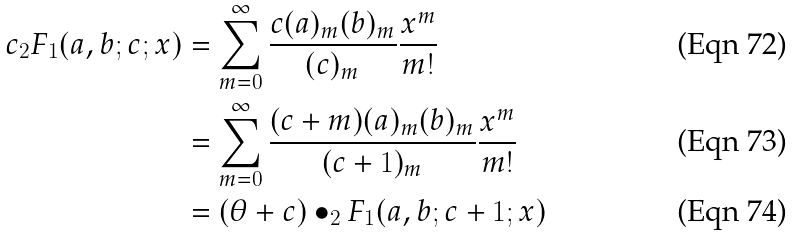<formula> <loc_0><loc_0><loc_500><loc_500>c _ { 2 } F _ { 1 } ( a , b ; c ; x ) & = \sum _ { m = 0 } ^ { \infty } \frac { c ( a ) _ { m } ( b ) _ { m } } { ( c ) _ { m } } \frac { x ^ { m } } { m ! } \\ & = \sum _ { m = 0 } ^ { \infty } \frac { ( c + m ) ( a ) _ { m } ( b ) _ { m } } { ( c + 1 ) _ { m } } \frac { x ^ { m } } { m ! } \\ & = ( \theta + c ) \bullet _ { 2 } F _ { 1 } ( a , b ; c + 1 ; x )</formula> 